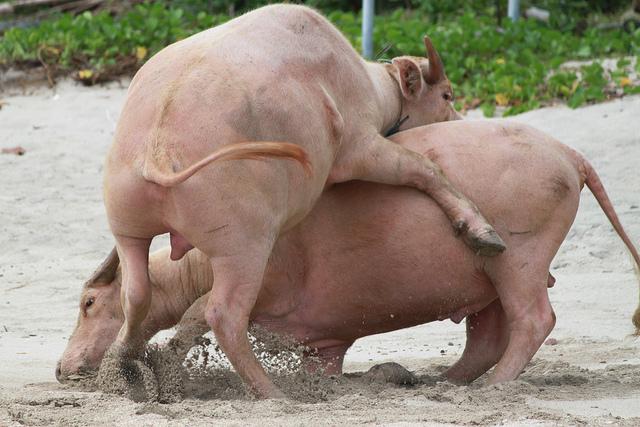Is the animal trying to take a nap?
Be succinct. No. What color are they?
Give a very brief answer. Pink. Is the bottom animal male or female?
Give a very brief answer. Male. What are they doing?
Concise answer only. Fighting. 